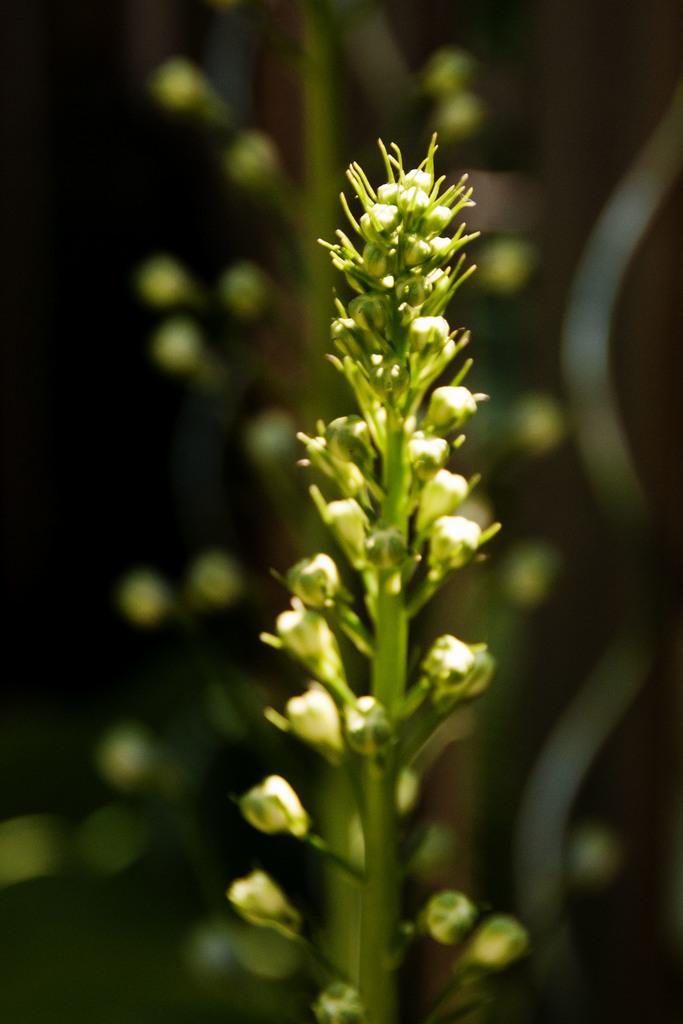Could you give a brief overview of what you see in this image? In the front of the image I can see a plant. In the background of the image it is blurry. 